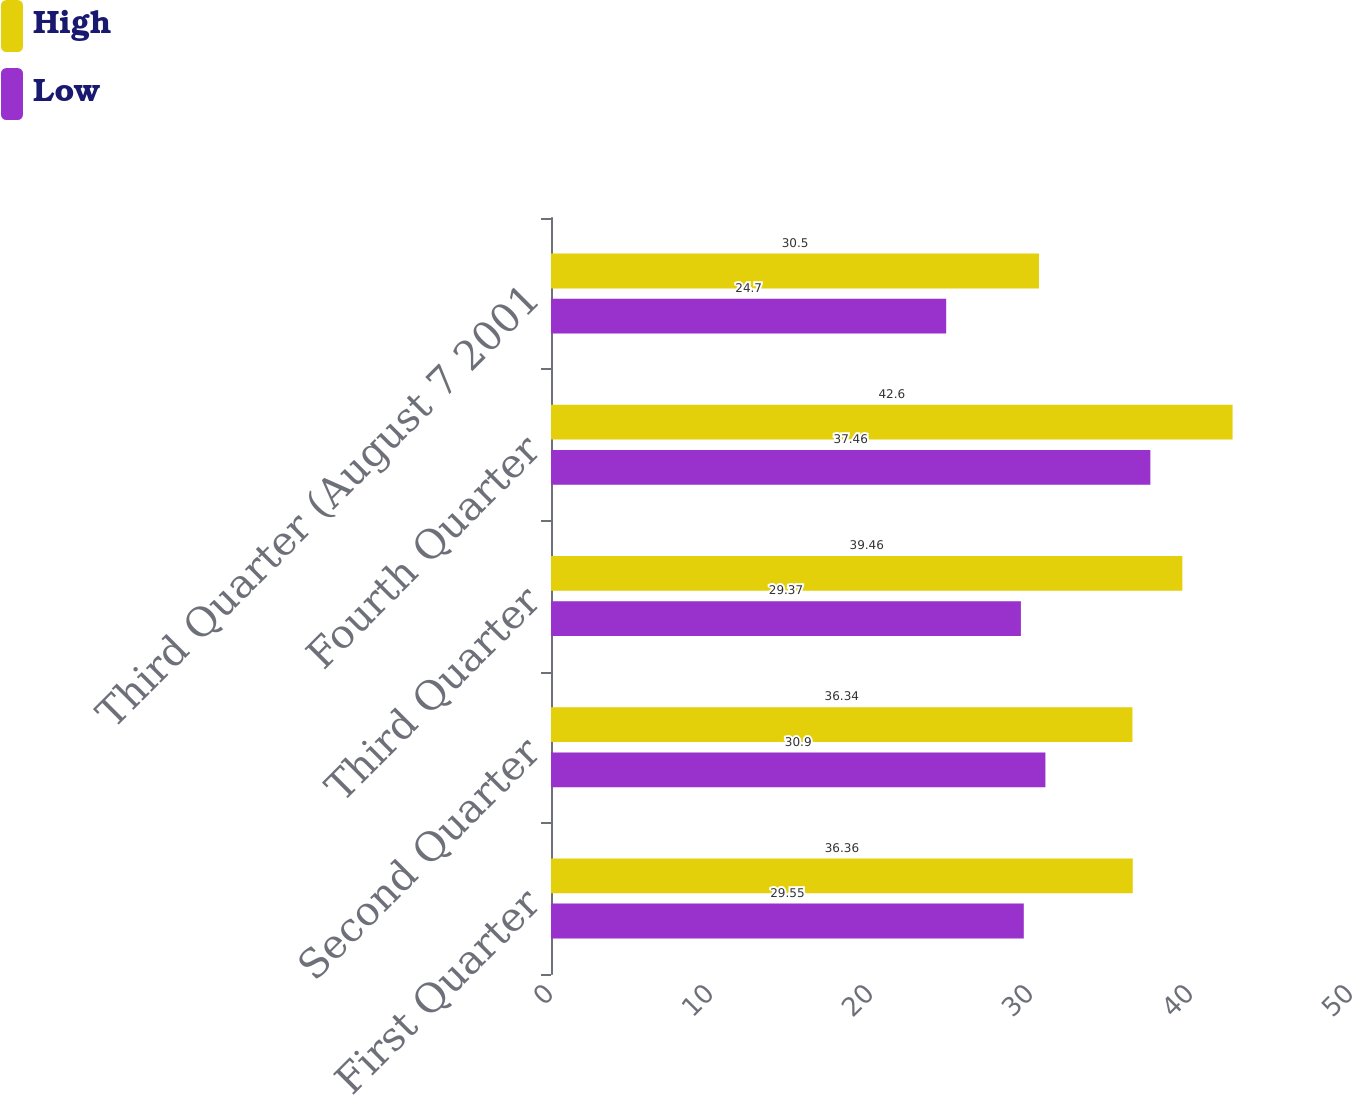<chart> <loc_0><loc_0><loc_500><loc_500><stacked_bar_chart><ecel><fcel>First Quarter<fcel>Second Quarter<fcel>Third Quarter<fcel>Fourth Quarter<fcel>Third Quarter (August 7 2001<nl><fcel>High<fcel>36.36<fcel>36.34<fcel>39.46<fcel>42.6<fcel>30.5<nl><fcel>Low<fcel>29.55<fcel>30.9<fcel>29.37<fcel>37.46<fcel>24.7<nl></chart> 